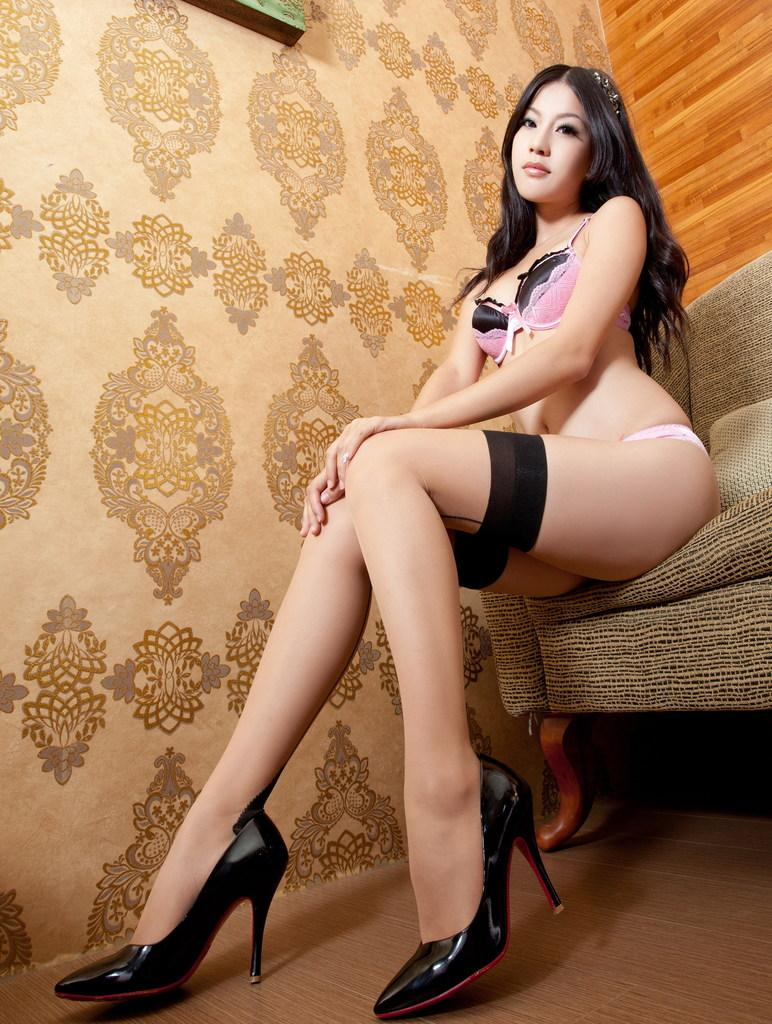What is the lady in the image doing? The lady is sitting on a couch in the image. Can you describe anything on the wall in the image? There is an object on the wall at the top of the image, and there is some design on the wall as well. What type of beef is being served on the table in the image? There is no table or beef present in the image; it only features a lady sitting on a couch and an object on the wall. 